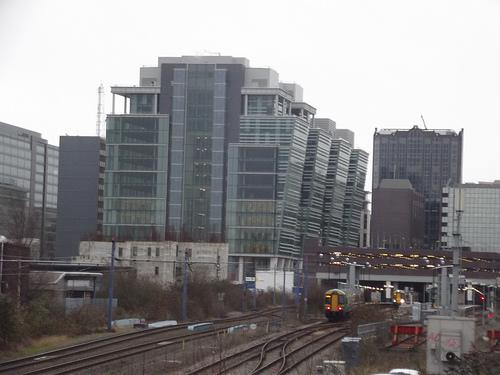Question: why are there tracks here?
Choices:
A. For the trains.
B. For a trolley.
C. Because animals made them.
D. For cars.
Answer with the letter. Answer: A Question: what is the setting?
Choices:
A. The beach.
B. The country.
C. A city.
D. The park.
Answer with the letter. Answer: C Question: where is the train heading?
Choices:
A. To the left.
B. To the right.
C. Towards the camera.
D. Away from the camera.
Answer with the letter. Answer: C Question: what is the sky like?
Choices:
A. Gray.
B. Sunny.
C. Stormy.
D. Dark.
Answer with the letter. Answer: A Question: what is shining on the train?
Choices:
A. Headlights.
B. The sun.
C. The paint.
D. The chrome.
Answer with the letter. Answer: A 